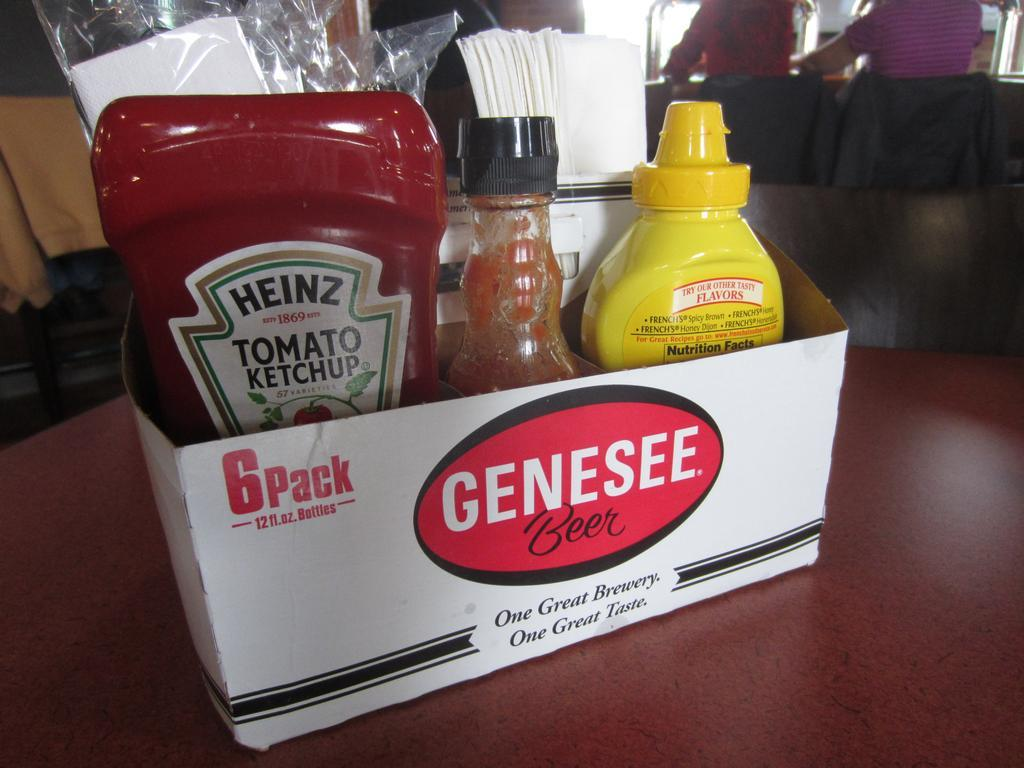Can you elaborate on the elements of the picture provided? The image captures a practical yet charming scene in a casual dining restaurant. A 6-pack cardboard holder, originally for Genesee Beer, is cleverly reused as a condiment caddy. This innovative repurposing not only speaks to a sustainability effort but also adds a nostalgic charm to the table setting. Displayed prominently on the caddy are the words 'One Great Brewery. One Great Taste.', which not only advertises the beer but also complements the diner's experience.

Within the caddy, there are three quintessential American condiments: Heinz Tomato Ketchup, Frank's RedHot Original Cayenne Pepper Sauce, and French's Classic Yellow Mustard. These condiments are staples in many American eateries, ready to enhance anything from burgers to fries. Also included are neatly packed white napkins, essential for a tidy meal. This setup not only ensures functionality and efficiency for the diners but also subtly promotes Genesee Beer amidst the casual dining experience. The background hints at a bustling environment, suggesting the restaurant is a popular choice among locals. 